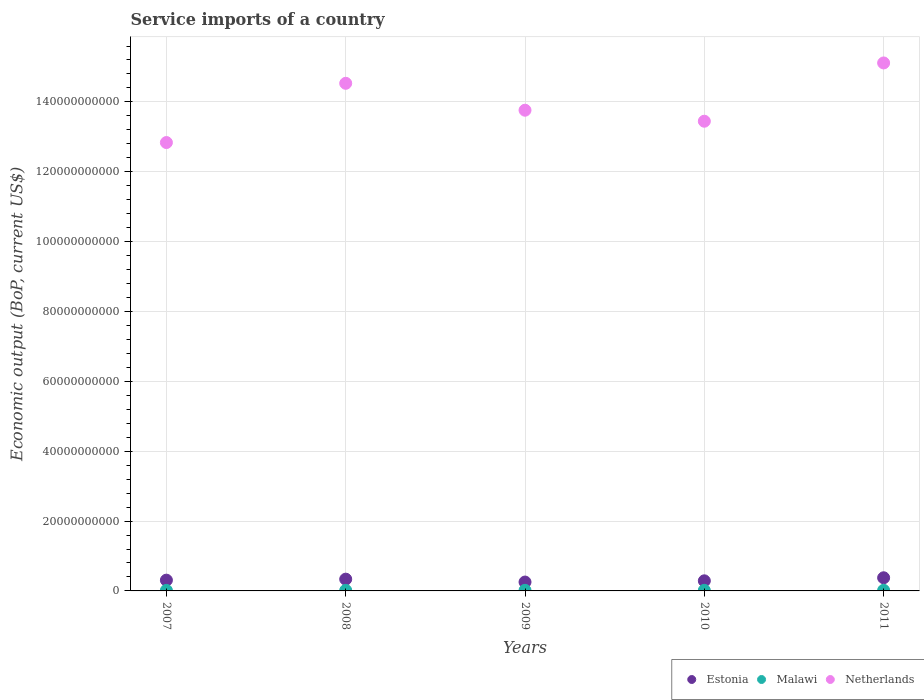How many different coloured dotlines are there?
Provide a short and direct response. 3. What is the service imports in Netherlands in 2009?
Keep it short and to the point. 1.38e+11. Across all years, what is the maximum service imports in Netherlands?
Offer a terse response. 1.51e+11. Across all years, what is the minimum service imports in Estonia?
Provide a succinct answer. 2.54e+09. In which year was the service imports in Estonia maximum?
Offer a terse response. 2011. In which year was the service imports in Netherlands minimum?
Give a very brief answer. 2007. What is the total service imports in Malawi in the graph?
Give a very brief answer. 8.28e+08. What is the difference between the service imports in Malawi in 2010 and that in 2011?
Ensure brevity in your answer.  -8.56e+06. What is the difference between the service imports in Netherlands in 2009 and the service imports in Estonia in 2010?
Offer a terse response. 1.35e+11. What is the average service imports in Netherlands per year?
Your answer should be very brief. 1.39e+11. In the year 2009, what is the difference between the service imports in Estonia and service imports in Netherlands?
Offer a very short reply. -1.35e+11. In how many years, is the service imports in Malawi greater than 68000000000 US$?
Offer a terse response. 0. What is the ratio of the service imports in Netherlands in 2007 to that in 2010?
Provide a short and direct response. 0.95. Is the service imports in Malawi in 2009 less than that in 2011?
Make the answer very short. Yes. Is the difference between the service imports in Estonia in 2010 and 2011 greater than the difference between the service imports in Netherlands in 2010 and 2011?
Your answer should be compact. Yes. What is the difference between the highest and the second highest service imports in Estonia?
Your response must be concise. 3.96e+08. What is the difference between the highest and the lowest service imports in Malawi?
Give a very brief answer. 2.63e+07. Is the service imports in Estonia strictly less than the service imports in Netherlands over the years?
Offer a terse response. Yes. What is the difference between two consecutive major ticks on the Y-axis?
Provide a succinct answer. 2.00e+1. Does the graph contain grids?
Offer a terse response. Yes. How many legend labels are there?
Offer a very short reply. 3. How are the legend labels stacked?
Offer a terse response. Horizontal. What is the title of the graph?
Offer a very short reply. Service imports of a country. What is the label or title of the Y-axis?
Provide a succinct answer. Economic output (BoP, current US$). What is the Economic output (BoP, current US$) of Estonia in 2007?
Provide a short and direct response. 3.08e+09. What is the Economic output (BoP, current US$) of Malawi in 2007?
Keep it short and to the point. 1.53e+08. What is the Economic output (BoP, current US$) in Netherlands in 2007?
Your response must be concise. 1.28e+11. What is the Economic output (BoP, current US$) in Estonia in 2008?
Your answer should be very brief. 3.37e+09. What is the Economic output (BoP, current US$) in Malawi in 2008?
Your response must be concise. 1.59e+08. What is the Economic output (BoP, current US$) in Netherlands in 2008?
Give a very brief answer. 1.45e+11. What is the Economic output (BoP, current US$) in Estonia in 2009?
Ensure brevity in your answer.  2.54e+09. What is the Economic output (BoP, current US$) in Malawi in 2009?
Offer a terse response. 1.67e+08. What is the Economic output (BoP, current US$) in Netherlands in 2009?
Offer a very short reply. 1.38e+11. What is the Economic output (BoP, current US$) of Estonia in 2010?
Your answer should be compact. 2.89e+09. What is the Economic output (BoP, current US$) of Malawi in 2010?
Make the answer very short. 1.70e+08. What is the Economic output (BoP, current US$) of Netherlands in 2010?
Offer a terse response. 1.34e+11. What is the Economic output (BoP, current US$) in Estonia in 2011?
Give a very brief answer. 3.76e+09. What is the Economic output (BoP, current US$) in Malawi in 2011?
Your answer should be very brief. 1.79e+08. What is the Economic output (BoP, current US$) of Netherlands in 2011?
Give a very brief answer. 1.51e+11. Across all years, what is the maximum Economic output (BoP, current US$) of Estonia?
Your response must be concise. 3.76e+09. Across all years, what is the maximum Economic output (BoP, current US$) in Malawi?
Give a very brief answer. 1.79e+08. Across all years, what is the maximum Economic output (BoP, current US$) of Netherlands?
Your response must be concise. 1.51e+11. Across all years, what is the minimum Economic output (BoP, current US$) in Estonia?
Your answer should be very brief. 2.54e+09. Across all years, what is the minimum Economic output (BoP, current US$) of Malawi?
Your answer should be very brief. 1.53e+08. Across all years, what is the minimum Economic output (BoP, current US$) in Netherlands?
Offer a very short reply. 1.28e+11. What is the total Economic output (BoP, current US$) in Estonia in the graph?
Provide a succinct answer. 1.56e+1. What is the total Economic output (BoP, current US$) of Malawi in the graph?
Your answer should be compact. 8.28e+08. What is the total Economic output (BoP, current US$) in Netherlands in the graph?
Your response must be concise. 6.97e+11. What is the difference between the Economic output (BoP, current US$) of Estonia in 2007 and that in 2008?
Your response must be concise. -2.87e+08. What is the difference between the Economic output (BoP, current US$) in Malawi in 2007 and that in 2008?
Your response must be concise. -6.45e+06. What is the difference between the Economic output (BoP, current US$) in Netherlands in 2007 and that in 2008?
Provide a succinct answer. -1.70e+1. What is the difference between the Economic output (BoP, current US$) in Estonia in 2007 and that in 2009?
Your answer should be very brief. 5.38e+08. What is the difference between the Economic output (BoP, current US$) in Malawi in 2007 and that in 2009?
Your answer should be compact. -1.45e+07. What is the difference between the Economic output (BoP, current US$) in Netherlands in 2007 and that in 2009?
Your answer should be very brief. -9.26e+09. What is the difference between the Economic output (BoP, current US$) of Estonia in 2007 and that in 2010?
Keep it short and to the point. 1.89e+08. What is the difference between the Economic output (BoP, current US$) of Malawi in 2007 and that in 2010?
Your response must be concise. -1.77e+07. What is the difference between the Economic output (BoP, current US$) in Netherlands in 2007 and that in 2010?
Keep it short and to the point. -6.11e+09. What is the difference between the Economic output (BoP, current US$) of Estonia in 2007 and that in 2011?
Offer a very short reply. -6.83e+08. What is the difference between the Economic output (BoP, current US$) of Malawi in 2007 and that in 2011?
Provide a short and direct response. -2.63e+07. What is the difference between the Economic output (BoP, current US$) of Netherlands in 2007 and that in 2011?
Your answer should be very brief. -2.28e+1. What is the difference between the Economic output (BoP, current US$) in Estonia in 2008 and that in 2009?
Your response must be concise. 8.25e+08. What is the difference between the Economic output (BoP, current US$) in Malawi in 2008 and that in 2009?
Offer a very short reply. -8.05e+06. What is the difference between the Economic output (BoP, current US$) of Netherlands in 2008 and that in 2009?
Your answer should be compact. 7.70e+09. What is the difference between the Economic output (BoP, current US$) of Estonia in 2008 and that in 2010?
Offer a terse response. 4.76e+08. What is the difference between the Economic output (BoP, current US$) in Malawi in 2008 and that in 2010?
Provide a short and direct response. -1.13e+07. What is the difference between the Economic output (BoP, current US$) of Netherlands in 2008 and that in 2010?
Offer a very short reply. 1.09e+1. What is the difference between the Economic output (BoP, current US$) of Estonia in 2008 and that in 2011?
Your answer should be compact. -3.96e+08. What is the difference between the Economic output (BoP, current US$) of Malawi in 2008 and that in 2011?
Give a very brief answer. -1.98e+07. What is the difference between the Economic output (BoP, current US$) of Netherlands in 2008 and that in 2011?
Your answer should be compact. -5.83e+09. What is the difference between the Economic output (BoP, current US$) of Estonia in 2009 and that in 2010?
Provide a succinct answer. -3.49e+08. What is the difference between the Economic output (BoP, current US$) of Malawi in 2009 and that in 2010?
Provide a succinct answer. -3.21e+06. What is the difference between the Economic output (BoP, current US$) of Netherlands in 2009 and that in 2010?
Your response must be concise. 3.15e+09. What is the difference between the Economic output (BoP, current US$) in Estonia in 2009 and that in 2011?
Give a very brief answer. -1.22e+09. What is the difference between the Economic output (BoP, current US$) of Malawi in 2009 and that in 2011?
Your answer should be very brief. -1.18e+07. What is the difference between the Economic output (BoP, current US$) of Netherlands in 2009 and that in 2011?
Keep it short and to the point. -1.35e+1. What is the difference between the Economic output (BoP, current US$) in Estonia in 2010 and that in 2011?
Keep it short and to the point. -8.72e+08. What is the difference between the Economic output (BoP, current US$) in Malawi in 2010 and that in 2011?
Provide a short and direct response. -8.56e+06. What is the difference between the Economic output (BoP, current US$) in Netherlands in 2010 and that in 2011?
Your answer should be compact. -1.67e+1. What is the difference between the Economic output (BoP, current US$) of Estonia in 2007 and the Economic output (BoP, current US$) of Malawi in 2008?
Give a very brief answer. 2.92e+09. What is the difference between the Economic output (BoP, current US$) in Estonia in 2007 and the Economic output (BoP, current US$) in Netherlands in 2008?
Give a very brief answer. -1.42e+11. What is the difference between the Economic output (BoP, current US$) in Malawi in 2007 and the Economic output (BoP, current US$) in Netherlands in 2008?
Ensure brevity in your answer.  -1.45e+11. What is the difference between the Economic output (BoP, current US$) of Estonia in 2007 and the Economic output (BoP, current US$) of Malawi in 2009?
Keep it short and to the point. 2.91e+09. What is the difference between the Economic output (BoP, current US$) in Estonia in 2007 and the Economic output (BoP, current US$) in Netherlands in 2009?
Provide a succinct answer. -1.35e+11. What is the difference between the Economic output (BoP, current US$) in Malawi in 2007 and the Economic output (BoP, current US$) in Netherlands in 2009?
Your answer should be compact. -1.37e+11. What is the difference between the Economic output (BoP, current US$) in Estonia in 2007 and the Economic output (BoP, current US$) in Malawi in 2010?
Ensure brevity in your answer.  2.91e+09. What is the difference between the Economic output (BoP, current US$) of Estonia in 2007 and the Economic output (BoP, current US$) of Netherlands in 2010?
Offer a very short reply. -1.31e+11. What is the difference between the Economic output (BoP, current US$) in Malawi in 2007 and the Economic output (BoP, current US$) in Netherlands in 2010?
Your answer should be very brief. -1.34e+11. What is the difference between the Economic output (BoP, current US$) in Estonia in 2007 and the Economic output (BoP, current US$) in Malawi in 2011?
Offer a terse response. 2.90e+09. What is the difference between the Economic output (BoP, current US$) in Estonia in 2007 and the Economic output (BoP, current US$) in Netherlands in 2011?
Keep it short and to the point. -1.48e+11. What is the difference between the Economic output (BoP, current US$) in Malawi in 2007 and the Economic output (BoP, current US$) in Netherlands in 2011?
Make the answer very short. -1.51e+11. What is the difference between the Economic output (BoP, current US$) of Estonia in 2008 and the Economic output (BoP, current US$) of Malawi in 2009?
Ensure brevity in your answer.  3.20e+09. What is the difference between the Economic output (BoP, current US$) in Estonia in 2008 and the Economic output (BoP, current US$) in Netherlands in 2009?
Make the answer very short. -1.34e+11. What is the difference between the Economic output (BoP, current US$) of Malawi in 2008 and the Economic output (BoP, current US$) of Netherlands in 2009?
Ensure brevity in your answer.  -1.37e+11. What is the difference between the Economic output (BoP, current US$) in Estonia in 2008 and the Economic output (BoP, current US$) in Malawi in 2010?
Make the answer very short. 3.20e+09. What is the difference between the Economic output (BoP, current US$) of Estonia in 2008 and the Economic output (BoP, current US$) of Netherlands in 2010?
Your answer should be compact. -1.31e+11. What is the difference between the Economic output (BoP, current US$) in Malawi in 2008 and the Economic output (BoP, current US$) in Netherlands in 2010?
Make the answer very short. -1.34e+11. What is the difference between the Economic output (BoP, current US$) of Estonia in 2008 and the Economic output (BoP, current US$) of Malawi in 2011?
Your response must be concise. 3.19e+09. What is the difference between the Economic output (BoP, current US$) of Estonia in 2008 and the Economic output (BoP, current US$) of Netherlands in 2011?
Provide a short and direct response. -1.48e+11. What is the difference between the Economic output (BoP, current US$) in Malawi in 2008 and the Economic output (BoP, current US$) in Netherlands in 2011?
Make the answer very short. -1.51e+11. What is the difference between the Economic output (BoP, current US$) of Estonia in 2009 and the Economic output (BoP, current US$) of Malawi in 2010?
Your answer should be compact. 2.37e+09. What is the difference between the Economic output (BoP, current US$) of Estonia in 2009 and the Economic output (BoP, current US$) of Netherlands in 2010?
Provide a succinct answer. -1.32e+11. What is the difference between the Economic output (BoP, current US$) of Malawi in 2009 and the Economic output (BoP, current US$) of Netherlands in 2010?
Your answer should be very brief. -1.34e+11. What is the difference between the Economic output (BoP, current US$) of Estonia in 2009 and the Economic output (BoP, current US$) of Malawi in 2011?
Ensure brevity in your answer.  2.36e+09. What is the difference between the Economic output (BoP, current US$) in Estonia in 2009 and the Economic output (BoP, current US$) in Netherlands in 2011?
Your response must be concise. -1.49e+11. What is the difference between the Economic output (BoP, current US$) in Malawi in 2009 and the Economic output (BoP, current US$) in Netherlands in 2011?
Give a very brief answer. -1.51e+11. What is the difference between the Economic output (BoP, current US$) of Estonia in 2010 and the Economic output (BoP, current US$) of Malawi in 2011?
Provide a succinct answer. 2.71e+09. What is the difference between the Economic output (BoP, current US$) in Estonia in 2010 and the Economic output (BoP, current US$) in Netherlands in 2011?
Provide a succinct answer. -1.48e+11. What is the difference between the Economic output (BoP, current US$) of Malawi in 2010 and the Economic output (BoP, current US$) of Netherlands in 2011?
Your answer should be very brief. -1.51e+11. What is the average Economic output (BoP, current US$) of Estonia per year?
Your answer should be compact. 3.13e+09. What is the average Economic output (BoP, current US$) in Malawi per year?
Offer a very short reply. 1.66e+08. What is the average Economic output (BoP, current US$) of Netherlands per year?
Your answer should be compact. 1.39e+11. In the year 2007, what is the difference between the Economic output (BoP, current US$) in Estonia and Economic output (BoP, current US$) in Malawi?
Offer a very short reply. 2.93e+09. In the year 2007, what is the difference between the Economic output (BoP, current US$) in Estonia and Economic output (BoP, current US$) in Netherlands?
Ensure brevity in your answer.  -1.25e+11. In the year 2007, what is the difference between the Economic output (BoP, current US$) of Malawi and Economic output (BoP, current US$) of Netherlands?
Your response must be concise. -1.28e+11. In the year 2008, what is the difference between the Economic output (BoP, current US$) in Estonia and Economic output (BoP, current US$) in Malawi?
Make the answer very short. 3.21e+09. In the year 2008, what is the difference between the Economic output (BoP, current US$) of Estonia and Economic output (BoP, current US$) of Netherlands?
Ensure brevity in your answer.  -1.42e+11. In the year 2008, what is the difference between the Economic output (BoP, current US$) in Malawi and Economic output (BoP, current US$) in Netherlands?
Your answer should be very brief. -1.45e+11. In the year 2009, what is the difference between the Economic output (BoP, current US$) in Estonia and Economic output (BoP, current US$) in Malawi?
Keep it short and to the point. 2.37e+09. In the year 2009, what is the difference between the Economic output (BoP, current US$) in Estonia and Economic output (BoP, current US$) in Netherlands?
Ensure brevity in your answer.  -1.35e+11. In the year 2009, what is the difference between the Economic output (BoP, current US$) in Malawi and Economic output (BoP, current US$) in Netherlands?
Offer a very short reply. -1.37e+11. In the year 2010, what is the difference between the Economic output (BoP, current US$) in Estonia and Economic output (BoP, current US$) in Malawi?
Ensure brevity in your answer.  2.72e+09. In the year 2010, what is the difference between the Economic output (BoP, current US$) of Estonia and Economic output (BoP, current US$) of Netherlands?
Make the answer very short. -1.32e+11. In the year 2010, what is the difference between the Economic output (BoP, current US$) in Malawi and Economic output (BoP, current US$) in Netherlands?
Offer a very short reply. -1.34e+11. In the year 2011, what is the difference between the Economic output (BoP, current US$) in Estonia and Economic output (BoP, current US$) in Malawi?
Your answer should be compact. 3.58e+09. In the year 2011, what is the difference between the Economic output (BoP, current US$) in Estonia and Economic output (BoP, current US$) in Netherlands?
Keep it short and to the point. -1.47e+11. In the year 2011, what is the difference between the Economic output (BoP, current US$) of Malawi and Economic output (BoP, current US$) of Netherlands?
Make the answer very short. -1.51e+11. What is the ratio of the Economic output (BoP, current US$) of Estonia in 2007 to that in 2008?
Keep it short and to the point. 0.91. What is the ratio of the Economic output (BoP, current US$) in Malawi in 2007 to that in 2008?
Keep it short and to the point. 0.96. What is the ratio of the Economic output (BoP, current US$) of Netherlands in 2007 to that in 2008?
Offer a terse response. 0.88. What is the ratio of the Economic output (BoP, current US$) of Estonia in 2007 to that in 2009?
Your response must be concise. 1.21. What is the ratio of the Economic output (BoP, current US$) in Malawi in 2007 to that in 2009?
Your response must be concise. 0.91. What is the ratio of the Economic output (BoP, current US$) in Netherlands in 2007 to that in 2009?
Your response must be concise. 0.93. What is the ratio of the Economic output (BoP, current US$) in Estonia in 2007 to that in 2010?
Your response must be concise. 1.07. What is the ratio of the Economic output (BoP, current US$) of Malawi in 2007 to that in 2010?
Provide a short and direct response. 0.9. What is the ratio of the Economic output (BoP, current US$) of Netherlands in 2007 to that in 2010?
Provide a short and direct response. 0.95. What is the ratio of the Economic output (BoP, current US$) of Estonia in 2007 to that in 2011?
Offer a very short reply. 0.82. What is the ratio of the Economic output (BoP, current US$) in Malawi in 2007 to that in 2011?
Make the answer very short. 0.85. What is the ratio of the Economic output (BoP, current US$) in Netherlands in 2007 to that in 2011?
Keep it short and to the point. 0.85. What is the ratio of the Economic output (BoP, current US$) in Estonia in 2008 to that in 2009?
Give a very brief answer. 1.32. What is the ratio of the Economic output (BoP, current US$) of Malawi in 2008 to that in 2009?
Your answer should be compact. 0.95. What is the ratio of the Economic output (BoP, current US$) in Netherlands in 2008 to that in 2009?
Your answer should be very brief. 1.06. What is the ratio of the Economic output (BoP, current US$) in Estonia in 2008 to that in 2010?
Keep it short and to the point. 1.16. What is the ratio of the Economic output (BoP, current US$) of Malawi in 2008 to that in 2010?
Offer a terse response. 0.93. What is the ratio of the Economic output (BoP, current US$) in Netherlands in 2008 to that in 2010?
Offer a terse response. 1.08. What is the ratio of the Economic output (BoP, current US$) in Estonia in 2008 to that in 2011?
Your answer should be compact. 0.89. What is the ratio of the Economic output (BoP, current US$) in Malawi in 2008 to that in 2011?
Keep it short and to the point. 0.89. What is the ratio of the Economic output (BoP, current US$) in Netherlands in 2008 to that in 2011?
Make the answer very short. 0.96. What is the ratio of the Economic output (BoP, current US$) of Estonia in 2009 to that in 2010?
Offer a very short reply. 0.88. What is the ratio of the Economic output (BoP, current US$) in Malawi in 2009 to that in 2010?
Your response must be concise. 0.98. What is the ratio of the Economic output (BoP, current US$) in Netherlands in 2009 to that in 2010?
Ensure brevity in your answer.  1.02. What is the ratio of the Economic output (BoP, current US$) of Estonia in 2009 to that in 2011?
Provide a succinct answer. 0.68. What is the ratio of the Economic output (BoP, current US$) in Malawi in 2009 to that in 2011?
Offer a very short reply. 0.93. What is the ratio of the Economic output (BoP, current US$) of Netherlands in 2009 to that in 2011?
Your response must be concise. 0.91. What is the ratio of the Economic output (BoP, current US$) in Estonia in 2010 to that in 2011?
Offer a terse response. 0.77. What is the ratio of the Economic output (BoP, current US$) of Malawi in 2010 to that in 2011?
Keep it short and to the point. 0.95. What is the ratio of the Economic output (BoP, current US$) of Netherlands in 2010 to that in 2011?
Offer a terse response. 0.89. What is the difference between the highest and the second highest Economic output (BoP, current US$) of Estonia?
Your answer should be very brief. 3.96e+08. What is the difference between the highest and the second highest Economic output (BoP, current US$) in Malawi?
Offer a terse response. 8.56e+06. What is the difference between the highest and the second highest Economic output (BoP, current US$) in Netherlands?
Provide a short and direct response. 5.83e+09. What is the difference between the highest and the lowest Economic output (BoP, current US$) in Estonia?
Your answer should be very brief. 1.22e+09. What is the difference between the highest and the lowest Economic output (BoP, current US$) in Malawi?
Ensure brevity in your answer.  2.63e+07. What is the difference between the highest and the lowest Economic output (BoP, current US$) of Netherlands?
Provide a short and direct response. 2.28e+1. 